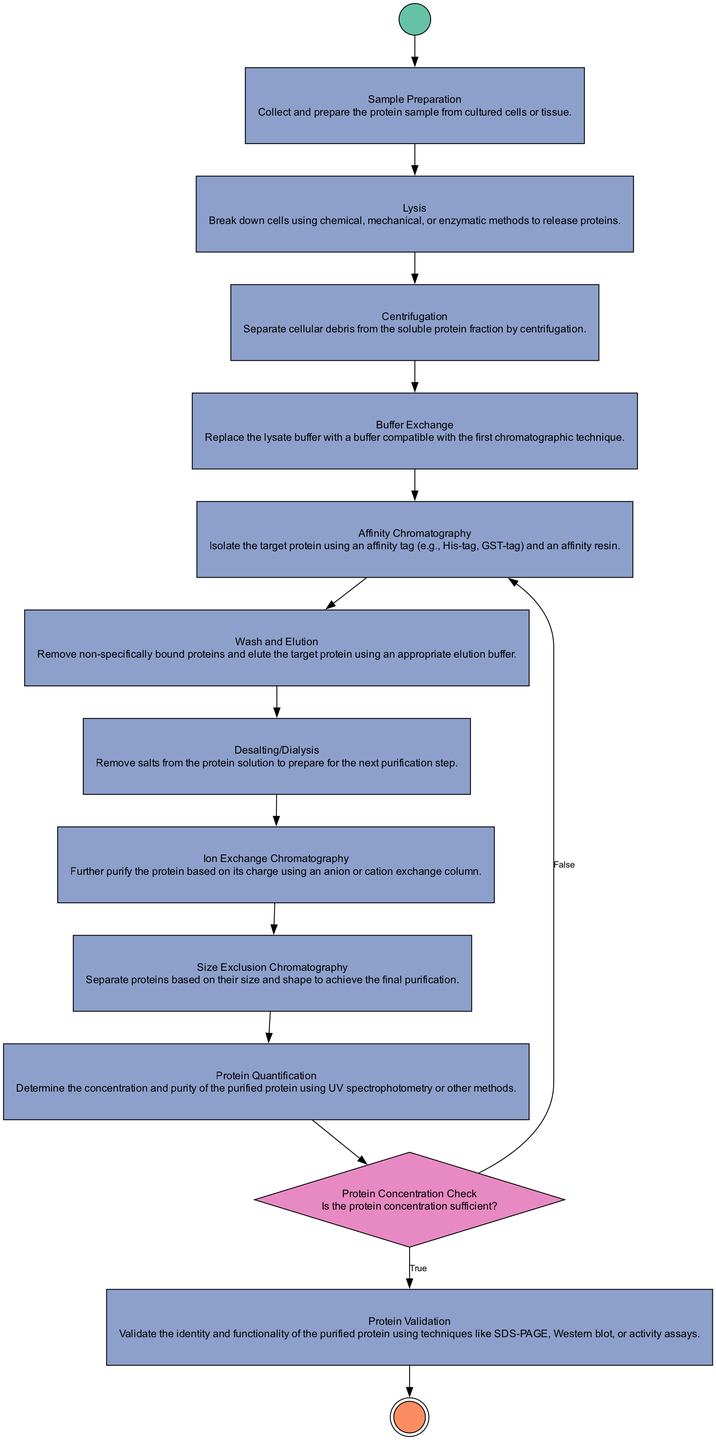What is the first action in the process? The diagram starts with the "Start Process" node, which leads to the "Sample Preparation" action. Therefore, the first action is "Sample Preparation."
Answer: Sample Preparation How many actions are there in total? By counting the activities labeled as actions in the diagram, there are 10 actions present.
Answer: 10 What happens if the protein concentration is insufficient? The diagram indicates that if the protein concentration is insufficient (False), the process returns to "Affinity Chromatography," suggesting it must revisit that step.
Answer: Affinity Chromatography What is the purpose of the "Protein Validation" action? The "Protein Validation" action is to validate the identity and functionality of the purified protein, ensuring accurate results after purification.
Answer: Validate identity and functionality Which action comes immediately after "Wash and Elution"? Following the "Wash and Elution" action, the next step in the process is "Desalting/Dialysis," indicating that removing salts follows elution.
Answer: Desalting/Dialysis What is the final step in the purification process? The last node in the diagram is the "End Process," indicating the completion of the protein purification procedures.
Answer: End Process How many decision points are present in the diagram? There is one decision labeled "Protein Concentration Check" which evaluates the sufficiency of protein concentration, indicating one decision point.
Answer: 1 What action follows "Protein Quantification"? After the "Protein Quantification," it leads to "Protein Concentration Check," indicating the process requires a concentration assessment next.
Answer: Protein Concentration Check What type of chromatography is used after buffer exchange? The next action after "Buffer Exchange" is "Affinity Chromatography," which specifies the type of chromatographic technique utilized at that stage.
Answer: Affinity Chromatography 